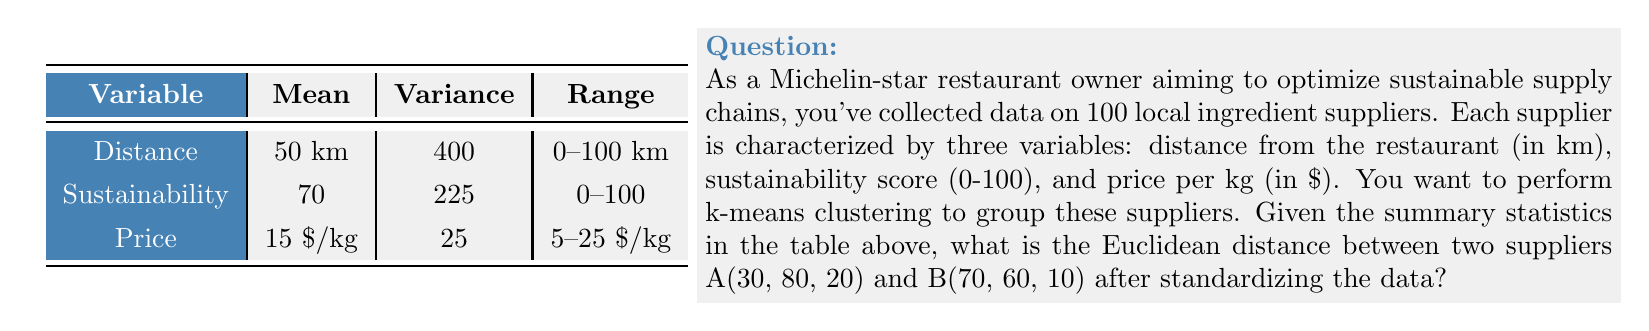What is the answer to this math problem? To solve this problem, we need to follow these steps:

1) First, we need to standardize the data. The formula for standardization is:

   $$z = \frac{x - \mu}{\sigma}$$

   where $x$ is the original value, $\mu$ is the mean, and $\sigma$ is the standard deviation.

2) We need to calculate the standard deviation for each variable:
   
   $$\sigma = \sqrt{\text{Variance}}$$

   Distance: $\sigma_d = \sqrt{400} = 20$
   Sustainability: $\sigma_s = \sqrt{225} = 15$
   Price: $\sigma_p = \sqrt{25} = 5$

3) Now, we can standardize the values for suppliers A and B:

   For A(30, 80, 20):
   $$z_{Ad} = \frac{30 - 50}{20} = -1$$
   $$z_{As} = \frac{80 - 70}{15} = \frac{2}{3}$$
   $$z_{Ap} = \frac{20 - 15}{5} = 1$$

   For B(70, 60, 10):
   $$z_{Bd} = \frac{70 - 50}{20} = 1$$
   $$z_{Bs} = \frac{60 - 70}{15} = -\frac{2}{3}$$
   $$z_{Bp} = \frac{10 - 15}{5} = -1$$

4) Now that we have the standardized coordinates, we can calculate the Euclidean distance:

   $$d = \sqrt{(z_{Ad} - z_{Bd})^2 + (z_{As} - z_{Bs})^2 + (z_{Ap} - z_{Bp})^2}$$

   $$d = \sqrt{(-1 - 1)^2 + (\frac{2}{3} - (-\frac{2}{3}))^2 + (1 - (-1))^2}$$

   $$d = \sqrt{(-2)^2 + (\frac{4}{3})^2 + 2^2}$$

   $$d = \sqrt{4 + \frac{16}{9} + 4}$$

   $$d = \sqrt{\frac{36}{9} + \frac{16}{9} + \frac{36}{9}}$$

   $$d = \sqrt{\frac{88}{9}} = \frac{2\sqrt{22}}{3}$$
Answer: $\frac{2\sqrt{22}}{3}$ 